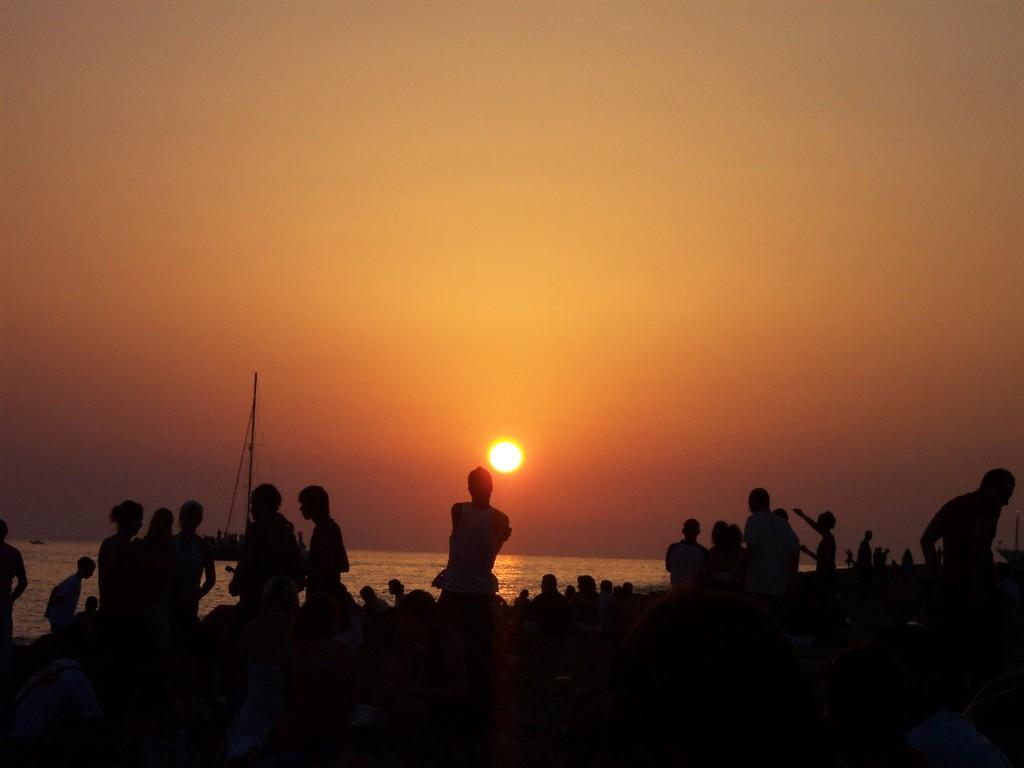What is the main subject of the image? The main subject of the image is a group of boys. Where are the boys located in the image? The boys are standing at the seaside. What time of day is depicted in the image? The image depicts a sunset. What can be seen in the background of the image? There is water visible in the image. What color is the sky in the image? The sky is red in color. What type of plate is being used by the boys to catch fish in the image? There is no plate or fishing activity present in the image. What kind of net is being used by the boys to catch fish in the image? There is no net or fishing activity present in the image. 